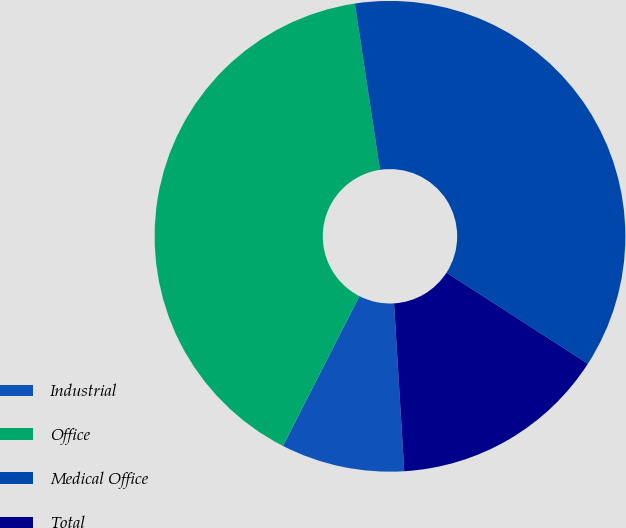Convert chart. <chart><loc_0><loc_0><loc_500><loc_500><pie_chart><fcel>Industrial<fcel>Office<fcel>Medical Office<fcel>Total<nl><fcel>8.48%<fcel>40.1%<fcel>36.49%<fcel>14.93%<nl></chart> 